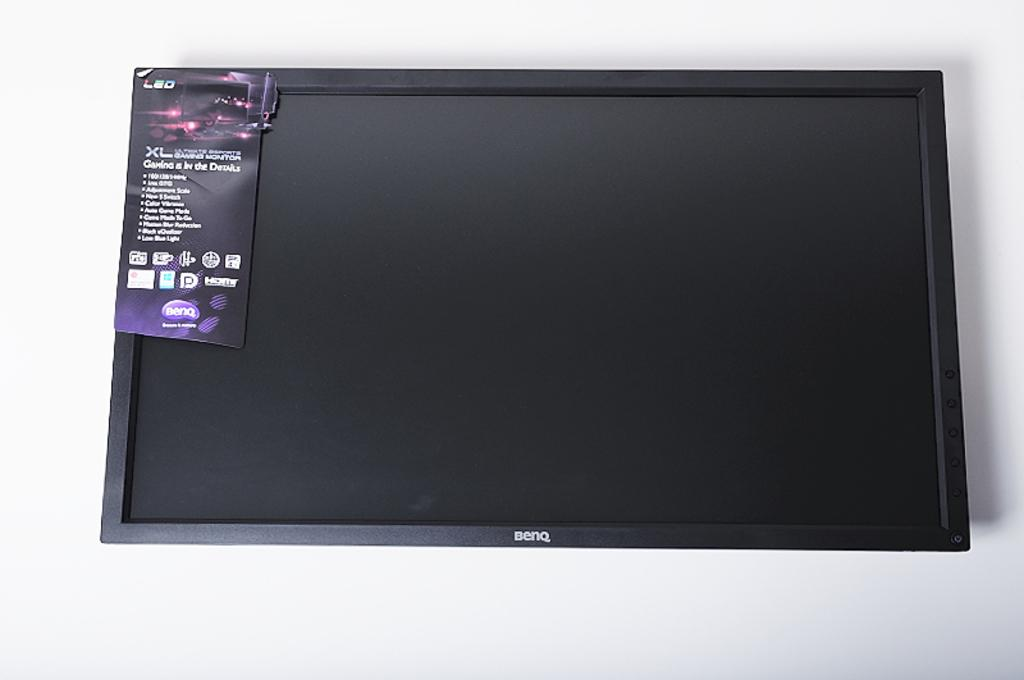<image>
Create a compact narrative representing the image presented. Front of a benq computer screen, with sales tag still on the top left, photographed on a white surface. 